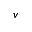<formula> <loc_0><loc_0><loc_500><loc_500>v</formula> 